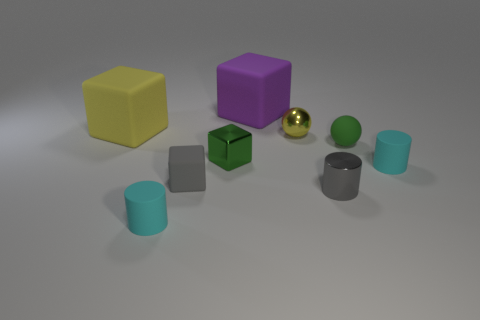What material is the tiny cylinder that is the same color as the tiny matte block? The small cylinder that shares its matte gray color with the small block appears to be made of metal, a common material choice for such items due to its durability and structural properties. 